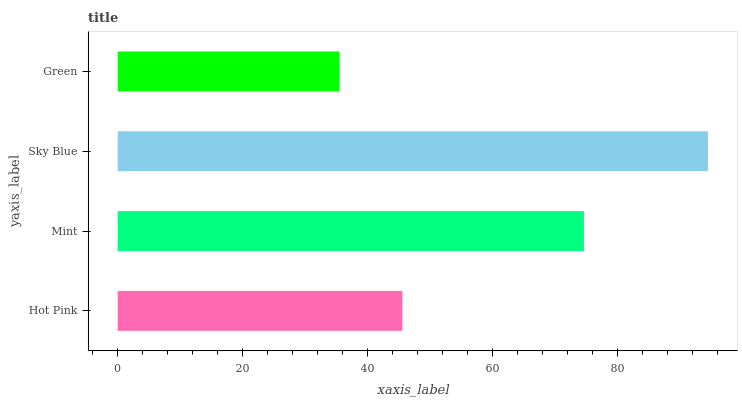Is Green the minimum?
Answer yes or no. Yes. Is Sky Blue the maximum?
Answer yes or no. Yes. Is Mint the minimum?
Answer yes or no. No. Is Mint the maximum?
Answer yes or no. No. Is Mint greater than Hot Pink?
Answer yes or no. Yes. Is Hot Pink less than Mint?
Answer yes or no. Yes. Is Hot Pink greater than Mint?
Answer yes or no. No. Is Mint less than Hot Pink?
Answer yes or no. No. Is Mint the high median?
Answer yes or no. Yes. Is Hot Pink the low median?
Answer yes or no. Yes. Is Sky Blue the high median?
Answer yes or no. No. Is Green the low median?
Answer yes or no. No. 